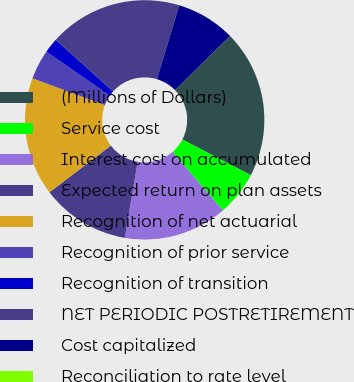<chart> <loc_0><loc_0><loc_500><loc_500><pie_chart><fcel>(Millions of Dollars)<fcel>Service cost<fcel>Interest cost on accumulated<fcel>Expected return on plan assets<fcel>Recognition of net actuarial<fcel>Recognition of prior service<fcel>Recognition of transition<fcel>NET PERIODIC POSTRETIREMENT<fcel>Cost capitalized<fcel>Reconciliation to rate level<nl><fcel>19.99%<fcel>6.0%<fcel>14.0%<fcel>12.0%<fcel>15.99%<fcel>4.01%<fcel>2.01%<fcel>17.99%<fcel>8.0%<fcel>0.01%<nl></chart> 